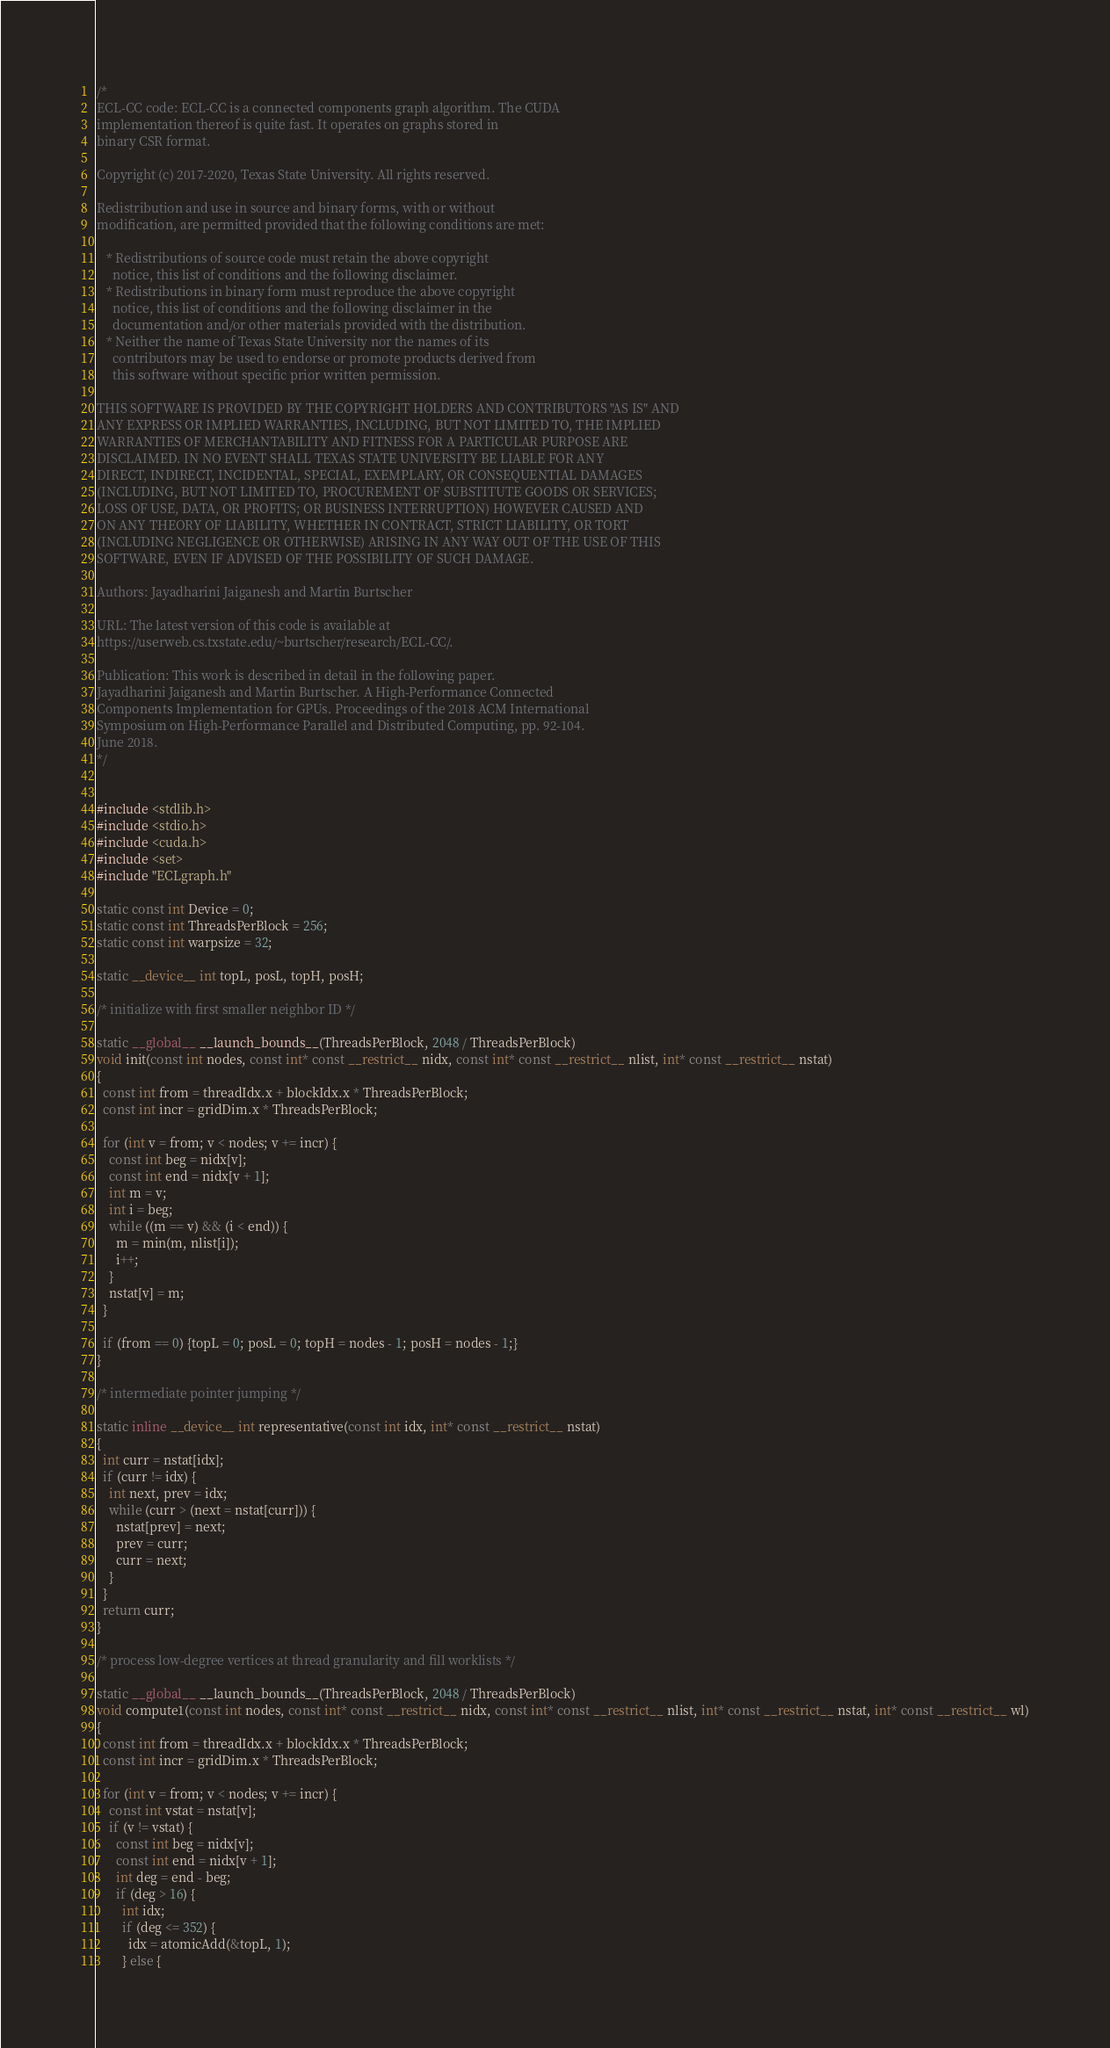<code> <loc_0><loc_0><loc_500><loc_500><_Cuda_>/*
ECL-CC code: ECL-CC is a connected components graph algorithm. The CUDA
implementation thereof is quite fast. It operates on graphs stored in
binary CSR format.

Copyright (c) 2017-2020, Texas State University. All rights reserved.

Redistribution and use in source and binary forms, with or without
modification, are permitted provided that the following conditions are met:

   * Redistributions of source code must retain the above copyright
     notice, this list of conditions and the following disclaimer.
   * Redistributions in binary form must reproduce the above copyright
     notice, this list of conditions and the following disclaimer in the
     documentation and/or other materials provided with the distribution.
   * Neither the name of Texas State University nor the names of its
     contributors may be used to endorse or promote products derived from
     this software without specific prior written permission.

THIS SOFTWARE IS PROVIDED BY THE COPYRIGHT HOLDERS AND CONTRIBUTORS "AS IS" AND
ANY EXPRESS OR IMPLIED WARRANTIES, INCLUDING, BUT NOT LIMITED TO, THE IMPLIED
WARRANTIES OF MERCHANTABILITY AND FITNESS FOR A PARTICULAR PURPOSE ARE
DISCLAIMED. IN NO EVENT SHALL TEXAS STATE UNIVERSITY BE LIABLE FOR ANY
DIRECT, INDIRECT, INCIDENTAL, SPECIAL, EXEMPLARY, OR CONSEQUENTIAL DAMAGES
(INCLUDING, BUT NOT LIMITED TO, PROCUREMENT OF SUBSTITUTE GOODS OR SERVICES;
LOSS OF USE, DATA, OR PROFITS; OR BUSINESS INTERRUPTION) HOWEVER CAUSED AND
ON ANY THEORY OF LIABILITY, WHETHER IN CONTRACT, STRICT LIABILITY, OR TORT
(INCLUDING NEGLIGENCE OR OTHERWISE) ARISING IN ANY WAY OUT OF THE USE OF THIS
SOFTWARE, EVEN IF ADVISED OF THE POSSIBILITY OF SUCH DAMAGE.

Authors: Jayadharini Jaiganesh and Martin Burtscher

URL: The latest version of this code is available at
https://userweb.cs.txstate.edu/~burtscher/research/ECL-CC/.

Publication: This work is described in detail in the following paper.
Jayadharini Jaiganesh and Martin Burtscher. A High-Performance Connected
Components Implementation for GPUs. Proceedings of the 2018 ACM International
Symposium on High-Performance Parallel and Distributed Computing, pp. 92-104.
June 2018.
*/


#include <stdlib.h>
#include <stdio.h>
#include <cuda.h>
#include <set>
#include "ECLgraph.h"

static const int Device = 0;
static const int ThreadsPerBlock = 256;
static const int warpsize = 32;

static __device__ int topL, posL, topH, posH;

/* initialize with first smaller neighbor ID */

static __global__ __launch_bounds__(ThreadsPerBlock, 2048 / ThreadsPerBlock)
void init(const int nodes, const int* const __restrict__ nidx, const int* const __restrict__ nlist, int* const __restrict__ nstat)
{
  const int from = threadIdx.x + blockIdx.x * ThreadsPerBlock;
  const int incr = gridDim.x * ThreadsPerBlock;

  for (int v = from; v < nodes; v += incr) {
    const int beg = nidx[v];
    const int end = nidx[v + 1];
    int m = v;
    int i = beg;
    while ((m == v) && (i < end)) {
      m = min(m, nlist[i]);
      i++;
    }
    nstat[v] = m;
  }

  if (from == 0) {topL = 0; posL = 0; topH = nodes - 1; posH = nodes - 1;}
}

/* intermediate pointer jumping */

static inline __device__ int representative(const int idx, int* const __restrict__ nstat)
{
  int curr = nstat[idx];
  if (curr != idx) {
    int next, prev = idx;
    while (curr > (next = nstat[curr])) {
      nstat[prev] = next;
      prev = curr;
      curr = next;
    }
  }
  return curr;
}

/* process low-degree vertices at thread granularity and fill worklists */

static __global__ __launch_bounds__(ThreadsPerBlock, 2048 / ThreadsPerBlock)
void compute1(const int nodes, const int* const __restrict__ nidx, const int* const __restrict__ nlist, int* const __restrict__ nstat, int* const __restrict__ wl)
{
  const int from = threadIdx.x + blockIdx.x * ThreadsPerBlock;
  const int incr = gridDim.x * ThreadsPerBlock;

  for (int v = from; v < nodes; v += incr) {
    const int vstat = nstat[v];
    if (v != vstat) {
      const int beg = nidx[v];
      const int end = nidx[v + 1];
      int deg = end - beg;
      if (deg > 16) {
        int idx;
        if (deg <= 352) {
          idx = atomicAdd(&topL, 1);
        } else {</code> 